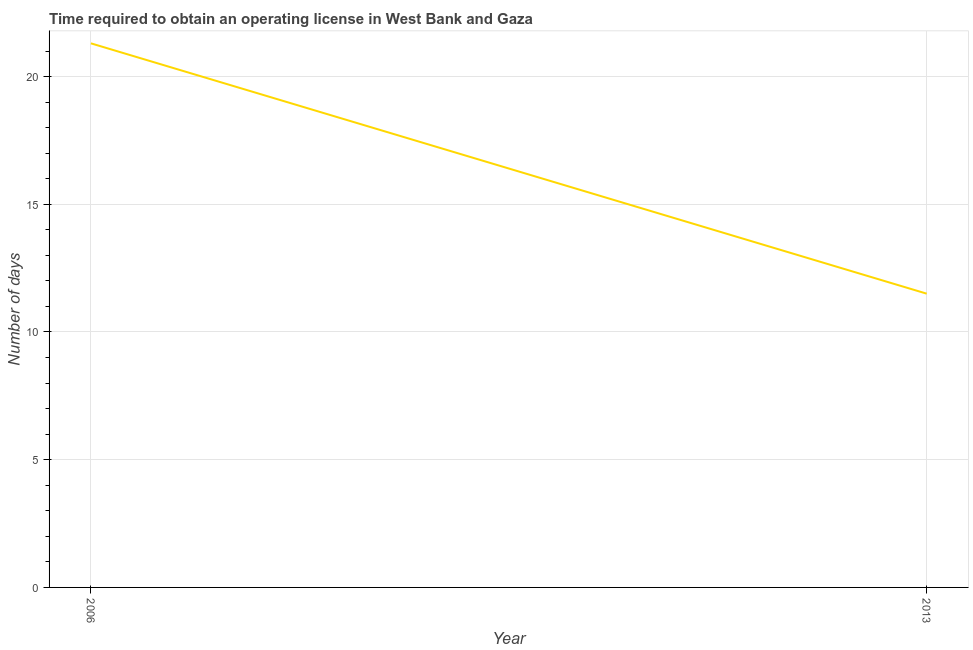What is the number of days to obtain operating license in 2013?
Your answer should be very brief. 11.5. Across all years, what is the maximum number of days to obtain operating license?
Your answer should be compact. 21.3. In which year was the number of days to obtain operating license maximum?
Your answer should be compact. 2006. In which year was the number of days to obtain operating license minimum?
Give a very brief answer. 2013. What is the sum of the number of days to obtain operating license?
Make the answer very short. 32.8. What is the difference between the number of days to obtain operating license in 2006 and 2013?
Your response must be concise. 9.8. In how many years, is the number of days to obtain operating license greater than 6 days?
Keep it short and to the point. 2. What is the ratio of the number of days to obtain operating license in 2006 to that in 2013?
Offer a terse response. 1.85. In how many years, is the number of days to obtain operating license greater than the average number of days to obtain operating license taken over all years?
Offer a very short reply. 1. How many years are there in the graph?
Provide a short and direct response. 2. What is the difference between two consecutive major ticks on the Y-axis?
Provide a short and direct response. 5. Does the graph contain grids?
Your answer should be very brief. Yes. What is the title of the graph?
Your answer should be compact. Time required to obtain an operating license in West Bank and Gaza. What is the label or title of the X-axis?
Offer a very short reply. Year. What is the label or title of the Y-axis?
Your answer should be very brief. Number of days. What is the Number of days in 2006?
Your response must be concise. 21.3. What is the difference between the Number of days in 2006 and 2013?
Keep it short and to the point. 9.8. What is the ratio of the Number of days in 2006 to that in 2013?
Ensure brevity in your answer.  1.85. 